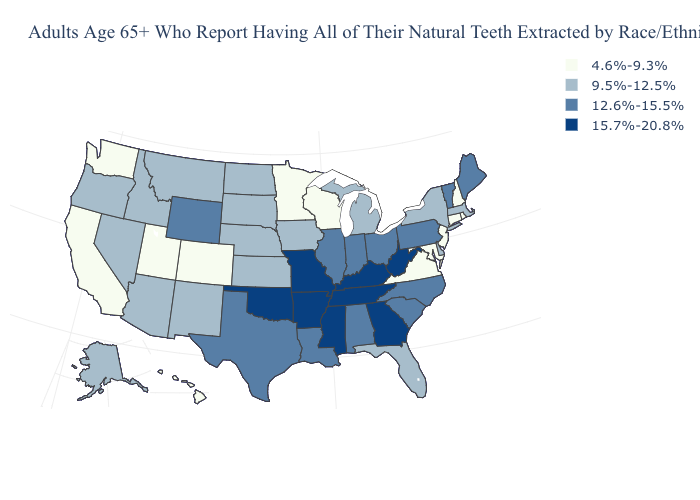Does Wyoming have the highest value in the West?
Short answer required. Yes. Which states have the lowest value in the USA?
Answer briefly. California, Colorado, Connecticut, Hawaii, Maryland, Minnesota, New Hampshire, New Jersey, Rhode Island, Utah, Virginia, Washington, Wisconsin. Does Arkansas have the highest value in the USA?
Be succinct. Yes. Is the legend a continuous bar?
Quick response, please. No. Does the map have missing data?
Short answer required. No. Name the states that have a value in the range 4.6%-9.3%?
Short answer required. California, Colorado, Connecticut, Hawaii, Maryland, Minnesota, New Hampshire, New Jersey, Rhode Island, Utah, Virginia, Washington, Wisconsin. What is the value of Minnesota?
Write a very short answer. 4.6%-9.3%. Does Wisconsin have the lowest value in the MidWest?
Concise answer only. Yes. Which states have the lowest value in the West?
Write a very short answer. California, Colorado, Hawaii, Utah, Washington. Does Maryland have the highest value in the USA?
Give a very brief answer. No. Name the states that have a value in the range 4.6%-9.3%?
Keep it brief. California, Colorado, Connecticut, Hawaii, Maryland, Minnesota, New Hampshire, New Jersey, Rhode Island, Utah, Virginia, Washington, Wisconsin. What is the value of Hawaii?
Give a very brief answer. 4.6%-9.3%. Does the first symbol in the legend represent the smallest category?
Be succinct. Yes. What is the lowest value in states that border Massachusetts?
Quick response, please. 4.6%-9.3%. Name the states that have a value in the range 15.7%-20.8%?
Give a very brief answer. Arkansas, Georgia, Kentucky, Mississippi, Missouri, Oklahoma, Tennessee, West Virginia. 